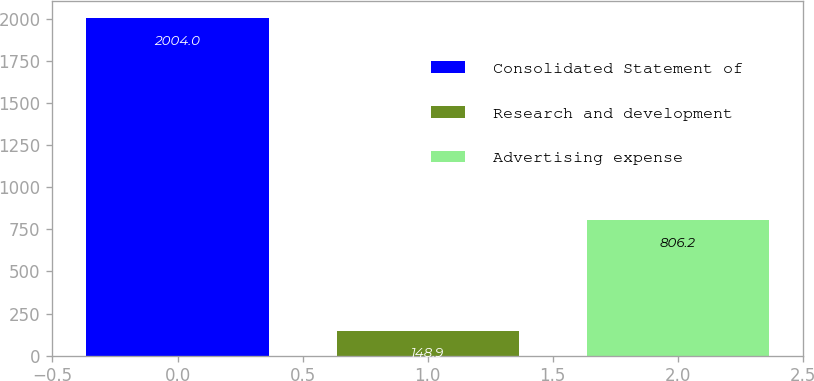<chart> <loc_0><loc_0><loc_500><loc_500><bar_chart><fcel>Consolidated Statement of<fcel>Research and development<fcel>Advertising expense<nl><fcel>2004<fcel>148.9<fcel>806.2<nl></chart> 